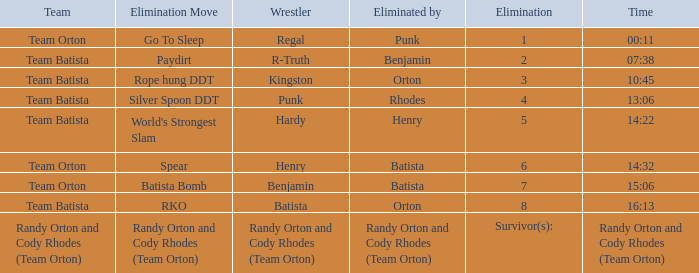Which Wrestler plays for Team Batista which was Elimated by Orton on Elimination 8? Batista. 